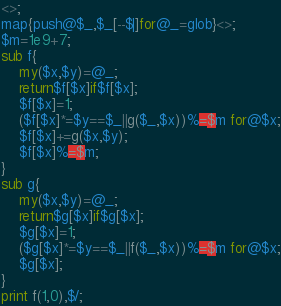Convert code to text. <code><loc_0><loc_0><loc_500><loc_500><_Perl_><>;
map{push@$_,$_[--$|]for@_=glob}<>;
$m=1e9+7;
sub f{
	my($x,$y)=@_;
	return$f[$x]if$f[$x];
	$f[$x]=1;
	($f[$x]*=$y==$_||g($_,$x))%=$m for@$x;
	$f[$x]+=g($x,$y);
	$f[$x]%=$m;
}
sub g{
	my($x,$y)=@_;
	return$g[$x]if$g[$x];
	$g[$x]=1;
	($g[$x]*=$y==$_||f($_,$x))%=$m for@$x;
	$g[$x];
}
print f(1,0),$/;</code> 